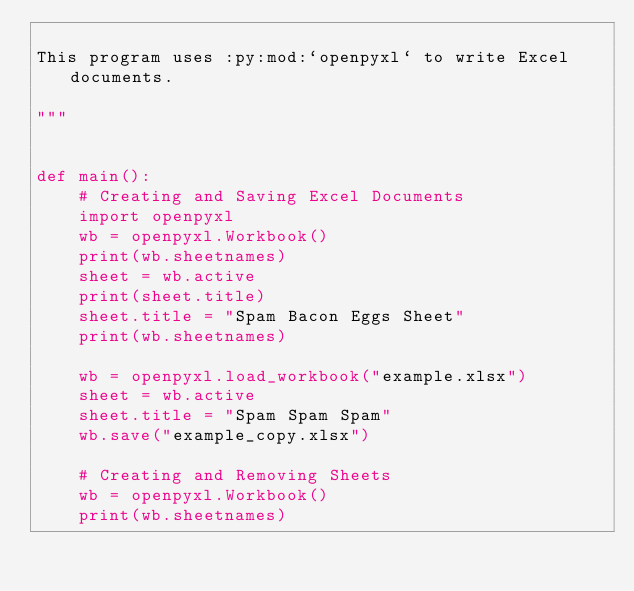<code> <loc_0><loc_0><loc_500><loc_500><_Python_>
This program uses :py:mod:`openpyxl` to write Excel documents.

"""


def main():
    # Creating and Saving Excel Documents
    import openpyxl
    wb = openpyxl.Workbook()
    print(wb.sheetnames)
    sheet = wb.active
    print(sheet.title)
    sheet.title = "Spam Bacon Eggs Sheet"
    print(wb.sheetnames)

    wb = openpyxl.load_workbook("example.xlsx")
    sheet = wb.active
    sheet.title = "Spam Spam Spam"
    wb.save("example_copy.xlsx")

    # Creating and Removing Sheets
    wb = openpyxl.Workbook()
    print(wb.sheetnames)</code> 